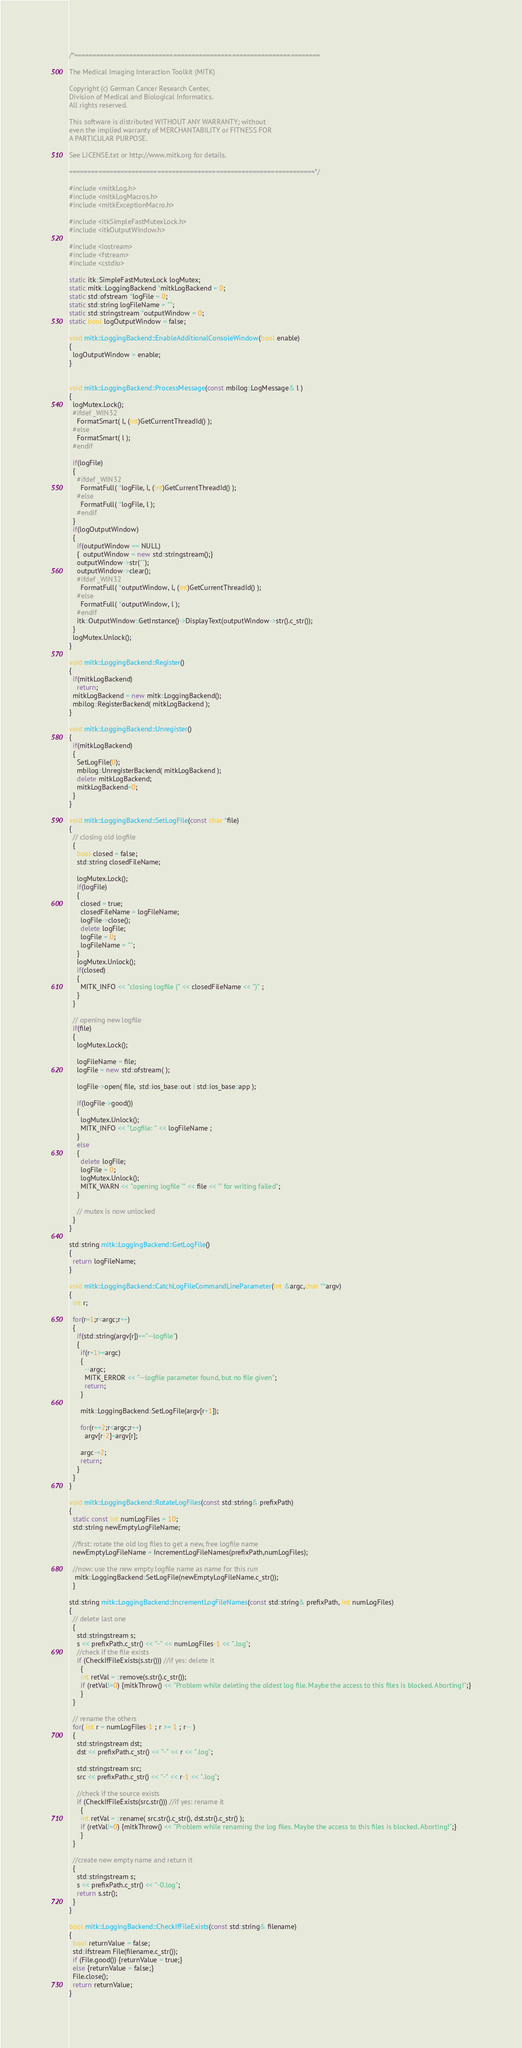Convert code to text. <code><loc_0><loc_0><loc_500><loc_500><_C++_>/*===================================================================

The Medical Imaging Interaction Toolkit (MITK)

Copyright (c) German Cancer Research Center,
Division of Medical and Biological Informatics.
All rights reserved.

This software is distributed WITHOUT ANY WARRANTY; without
even the implied warranty of MERCHANTABILITY or FITNESS FOR
A PARTICULAR PURPOSE.

See LICENSE.txt or http://www.mitk.org for details.

===================================================================*/

#include <mitkLog.h>
#include <mitkLogMacros.h>
#include <mitkExceptionMacro.h>

#include <itkSimpleFastMutexLock.h>
#include <itkOutputWindow.h>

#include <iostream>
#include <fstream>
#include <cstdio>

static itk::SimpleFastMutexLock logMutex;
static mitk::LoggingBackend *mitkLogBackend = 0;
static std::ofstream *logFile = 0;
static std::string logFileName = "";
static std::stringstream *outputWindow = 0;
static bool logOutputWindow = false;

void mitk::LoggingBackend::EnableAdditionalConsoleWindow(bool enable)
{
  logOutputWindow = enable;
}


void mitk::LoggingBackend::ProcessMessage(const mbilog::LogMessage& l )
{
  logMutex.Lock();
  #ifdef _WIN32
    FormatSmart( l, (int)GetCurrentThreadId() );
  #else
    FormatSmart( l );
  #endif

  if(logFile)
  {
    #ifdef _WIN32
      FormatFull( *logFile, l, (int)GetCurrentThreadId() );
    #else
      FormatFull( *logFile, l );
    #endif
  }
  if(logOutputWindow)
  {
    if(outputWindow == NULL)
    {  outputWindow = new std::stringstream();}
    outputWindow->str("");
    outputWindow->clear();
    #ifdef _WIN32
      FormatFull( *outputWindow, l, (int)GetCurrentThreadId() );
    #else
      FormatFull( *outputWindow, l );
    #endif
    itk::OutputWindow::GetInstance()->DisplayText(outputWindow->str().c_str());
  }
  logMutex.Unlock();
}

void mitk::LoggingBackend::Register()
{
  if(mitkLogBackend)
    return;
  mitkLogBackend = new mitk::LoggingBackend();
  mbilog::RegisterBackend( mitkLogBackend );
}

void mitk::LoggingBackend::Unregister()
{
  if(mitkLogBackend)
  {
    SetLogFile(0);
    mbilog::UnregisterBackend( mitkLogBackend );
    delete mitkLogBackend;
    mitkLogBackend=0;
  }
}

void mitk::LoggingBackend::SetLogFile(const char *file)
{
  // closing old logfile
  {
    bool closed = false;
    std::string closedFileName;

    logMutex.Lock();
    if(logFile)
    {
      closed = true;
      closedFileName = logFileName;
      logFile->close();
      delete logFile;
      logFile = 0;
      logFileName = "";
    }
    logMutex.Unlock();
    if(closed)
    {
      MITK_INFO << "closing logfile (" << closedFileName << ")" ;
    }
  }

  // opening new logfile
  if(file)
  {
    logMutex.Lock();

    logFileName = file;
    logFile = new std::ofstream( );

    logFile->open( file,  std::ios_base::out | std::ios_base::app );

    if(logFile->good())
    {
      logMutex.Unlock();
      MITK_INFO << "Logfile: " << logFileName ;
    }
    else
    {
      delete logFile;
      logFile = 0;
      logMutex.Unlock();
      MITK_WARN << "opening logfile '" << file << "' for writing failed";
    }

    // mutex is now unlocked
  }
}

std::string mitk::LoggingBackend::GetLogFile()
{
  return logFileName;
}

void mitk::LoggingBackend::CatchLogFileCommandLineParameter(int &argc,char **argv)
{
  int r;

  for(r=1;r<argc;r++)
  {
    if(std::string(argv[r])=="--logfile")
    {
      if(r+1>=argc)
      {
        --argc;
        MITK_ERROR << "--logfile parameter found, but no file given";
        return;
      }

      mitk::LoggingBackend::SetLogFile(argv[r+1]);

      for(r+=2;r<argc;r++)
        argv[r-2]=argv[r];

      argc-=2;
      return;
    }
  }
}

void mitk::LoggingBackend::RotateLogFiles(const std::string& prefixPath)
{
  static const int numLogFiles = 10;
  std::string newEmptyLogFileName;

  //first: rotate the old log files to get a new, free logfile name
  newEmptyLogFileName = IncrementLogFileNames(prefixPath,numLogFiles);

  //now: use the new empty logfile name as name for this run
   mitk::LoggingBackend::SetLogFile(newEmptyLogFileName.c_str());
  }

std::string mitk::LoggingBackend::IncrementLogFileNames(const std::string& prefixPath, int numLogFiles)
{
  // delete last one
  {
    std::stringstream s;
    s << prefixPath.c_str() << "-" << numLogFiles-1 << ".log";
    //check if the file exists
    if (CheckIfFileExists(s.str())) //if yes: delete it
      {
      int retVal = ::remove(s.str().c_str());
      if (retVal!=0) {mitkThrow() << "Problem while deleting the oldest log file. Maybe the access to this files is blocked. Aborting!";}
      }
  }

  // rename the others
  for( int r = numLogFiles-1 ; r >= 1 ; r-- )
  {
    std::stringstream dst;
    dst << prefixPath.c_str() << "-" << r << ".log";

    std::stringstream src;
    src << prefixPath.c_str() << "-" << r-1 << ".log";

    //check if the source exists
    if (CheckIfFileExists(src.str())) //if yes: rename it
      {
      int retVal = ::rename( src.str().c_str(), dst.str().c_str() );
      if (retVal!=0) {mitkThrow() << "Problem while renaming the log files. Maybe the access to this files is blocked. Aborting!";}
      }
  }

  //create new empty name and return it
  {
    std::stringstream s;
    s << prefixPath.c_str() << "-0.log";
    return s.str();
  }
}

bool mitk::LoggingBackend::CheckIfFileExists(const std::string& filename)
{
  bool returnValue = false;
  std::ifstream File(filename.c_str());
  if (File.good()) {returnValue = true;}
  else {returnValue = false;}
  File.close();
  return returnValue;
}
</code> 